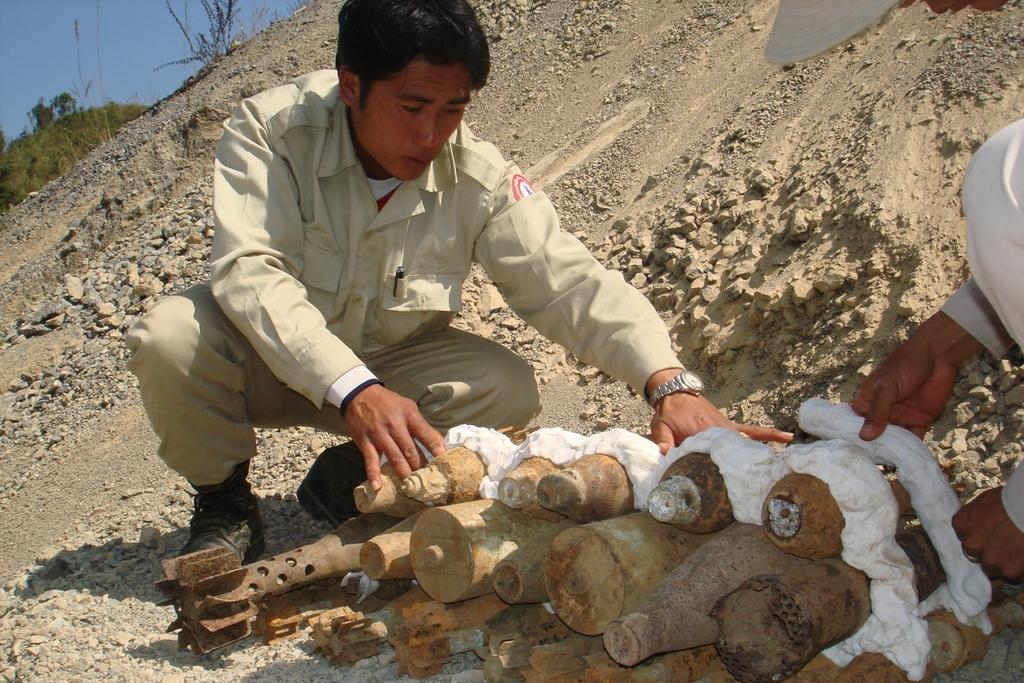Who is in the image? There is a man in the image. What is the man wearing? The man is wearing a brown shirt and pants. What is the man doing in the image? The man is sitting on the ground and arranging mine bombs. What can be seen in the background of the image? There are trees in the background of the image. What type of liquid is the man drinking in the image? There is no liquid present in the image; the man is arranging mine bombs while sitting on the ground. 